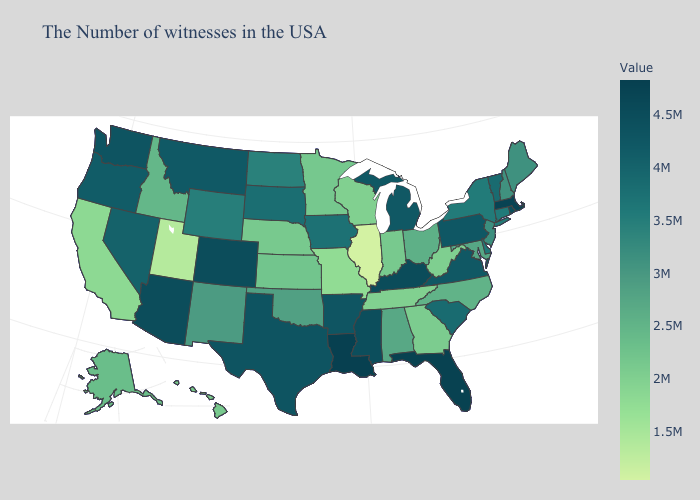Does Wyoming have the lowest value in the USA?
Write a very short answer. No. Among the states that border Nevada , which have the lowest value?
Keep it brief. Utah. Among the states that border Montana , does North Dakota have the highest value?
Be succinct. No. Among the states that border Washington , which have the lowest value?
Be succinct. Idaho. Does New Hampshire have the lowest value in the Northeast?
Short answer required. Yes. Does Illinois have the lowest value in the MidWest?
Short answer required. Yes. 